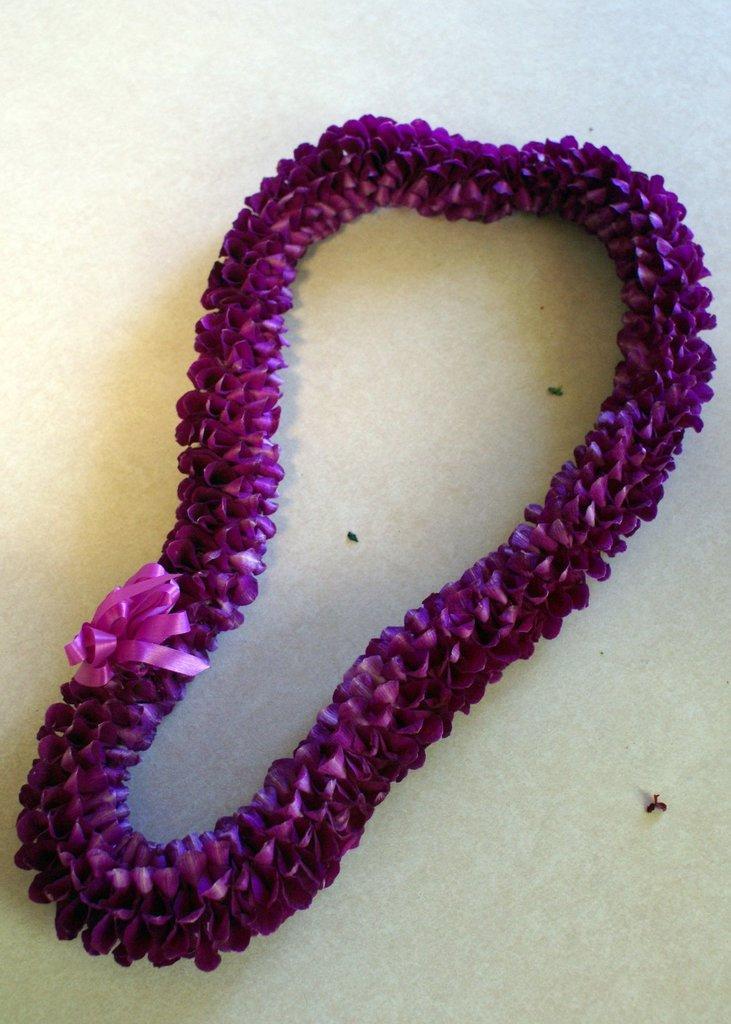In one or two sentences, can you explain what this image depicts? In this image there is a garland on a table. 